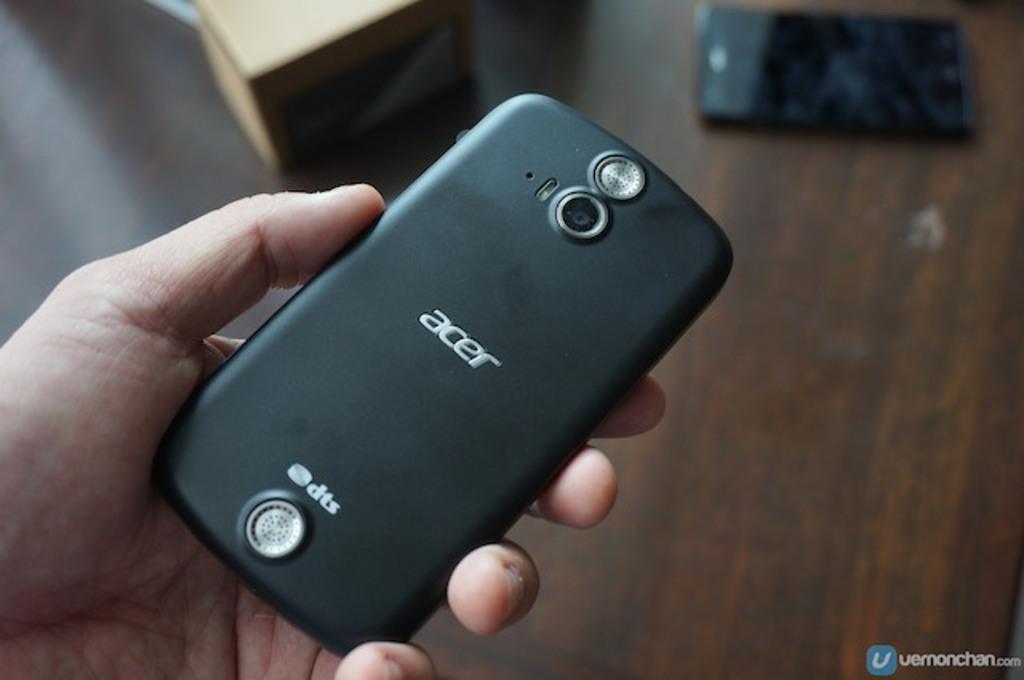What company made the phone?
Provide a short and direct response. Acer. 